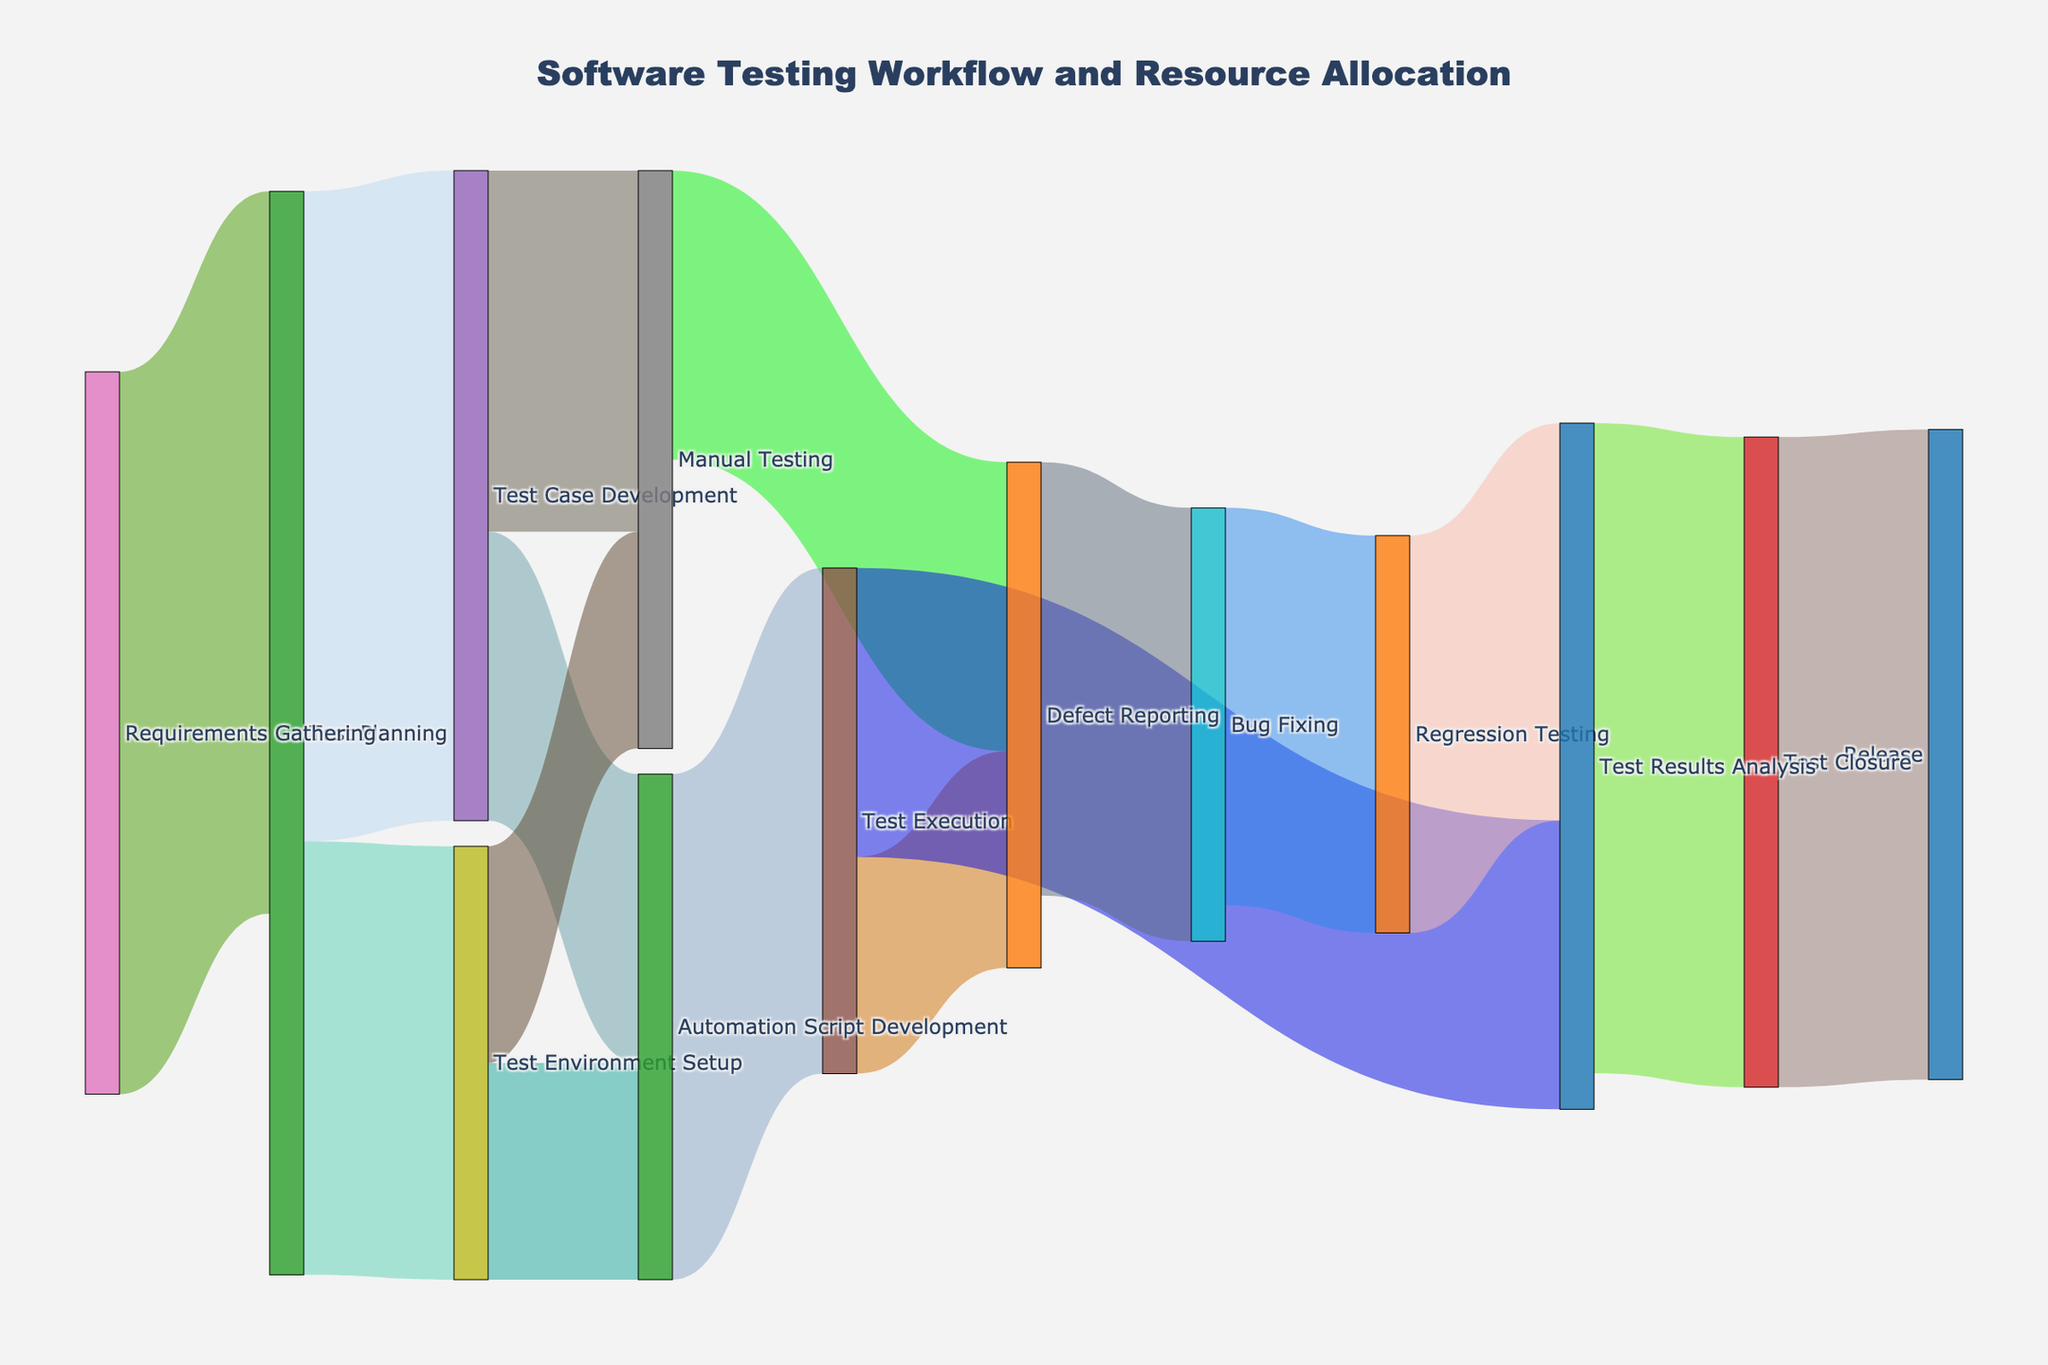what is the title of the sankey diagram? The title of the Sankey diagram is prominently displayed at the top of the figure. It provides a descriptive overview of what the diagram represents.
Answer: Software Testing Workflow and Resource Allocation What are the initial stages in the software testing workflow? By looking at the leftmost nodes in the Sankey diagram, we observe the starting points of the flow. These nodes represent the initial stages of the process.
Answer: Requirements Gathering How many resources are allocated to Test Planing from Requirements Gathering? The width of the flow from "Requirements Gathering" to "Test Planning" represents the amount of resources allocated. The specific value can be read directly from the diagram.
Answer: 100 What stages receive resources from Test Planning, and how much? To determine this, observe the branches that stem from "Test Planning" and note the values associated with each connection.
Answer: Test Case Development (90), Test Environment Setup (60) Which stage receives the most resources from Test Case Development? Compare the values of the flows originating from "Test Case Development" and find the maximum value to identify the stage.
Answer: Manual Testing (50) What is the total resources transitioning into Manual Testing? To find this, sum the values of all flows that lead to "Manual Testing." Observe the incoming connections and their respective values.
Answer: 50 (from Test Case Development) + 30 (from Test Environment Setup) = 80 Which stage receives resources from both Test Case Development and Test Environment Setup? Identify the stages that have incoming flows from both "Test Case Development" and "Test Environment Setup" by analyzing the diagram.
Answer: Automation Script Development What's the difference in resources between Defect Reporting and Bug Fixing? Observe the values for resources allocated to "Defect Reporting" and "Bug Fixing." Subtract the value for "Bug Fixing" from the value for "Defect Reporting" to find the difference.
Answer: 60 (Defect Reporting) - 55 (Bug Fixing) = 5 How many stages contribute resources to Test Results Analysis? Count the number of flows that direct resources into "Test Results Analysis." Each incoming flow represents a contributing stage.
Answer: 2 (from Test Execution and Regression Testing) Which stages contribute to the final stage, Release? Look at the flows leading into the "Release" stage and note the immediate preceding stages. In this case, follow the final flows to "Release."
Answer: Test Closure 